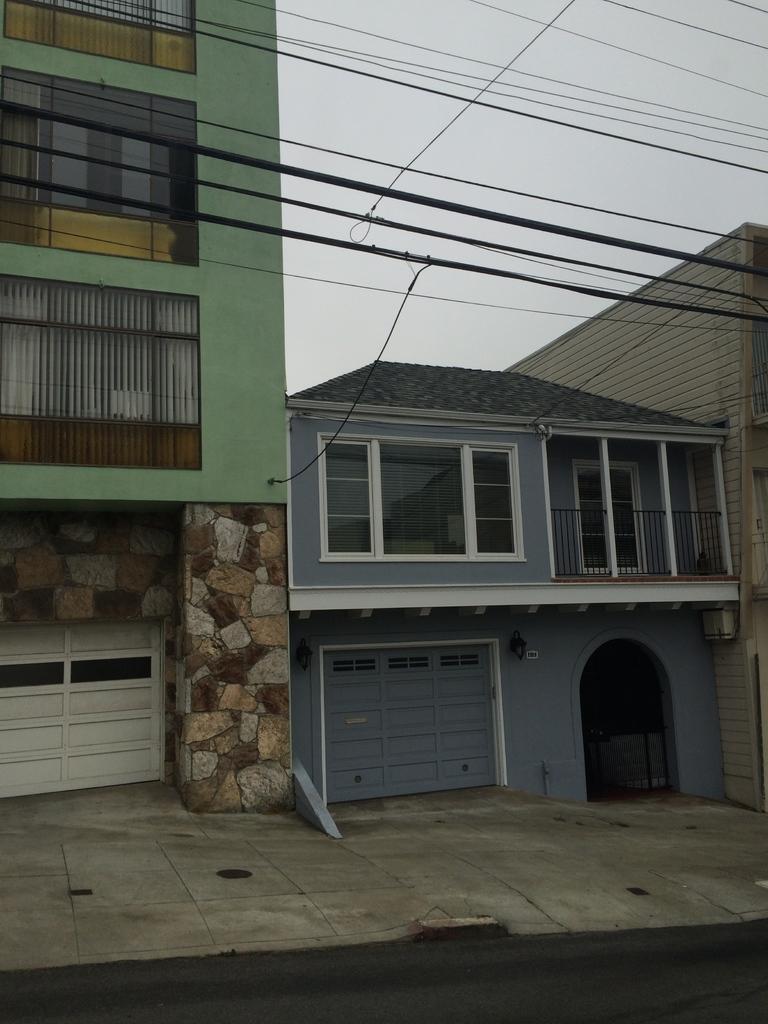Can you describe this image briefly? This image consists of buildings along with windows. At the bottom, we can see the gates. At the top, there are wires. And we can see the sky. 